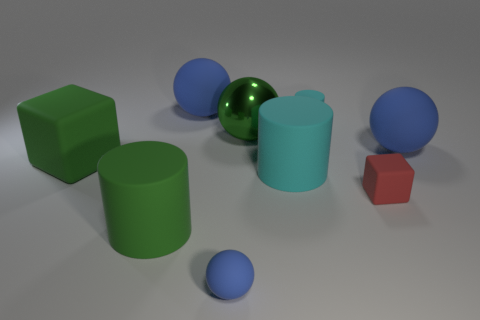Subtract all blue spheres. How many were subtracted if there are1blue spheres left? 2 Subtract all brown cubes. How many blue balls are left? 3 Add 1 blue spheres. How many objects exist? 10 Subtract all cylinders. How many objects are left? 6 Add 7 big cyan things. How many big cyan things are left? 8 Add 5 purple rubber objects. How many purple rubber objects exist? 5 Subtract 0 red cylinders. How many objects are left? 9 Subtract all small blocks. Subtract all green blocks. How many objects are left? 7 